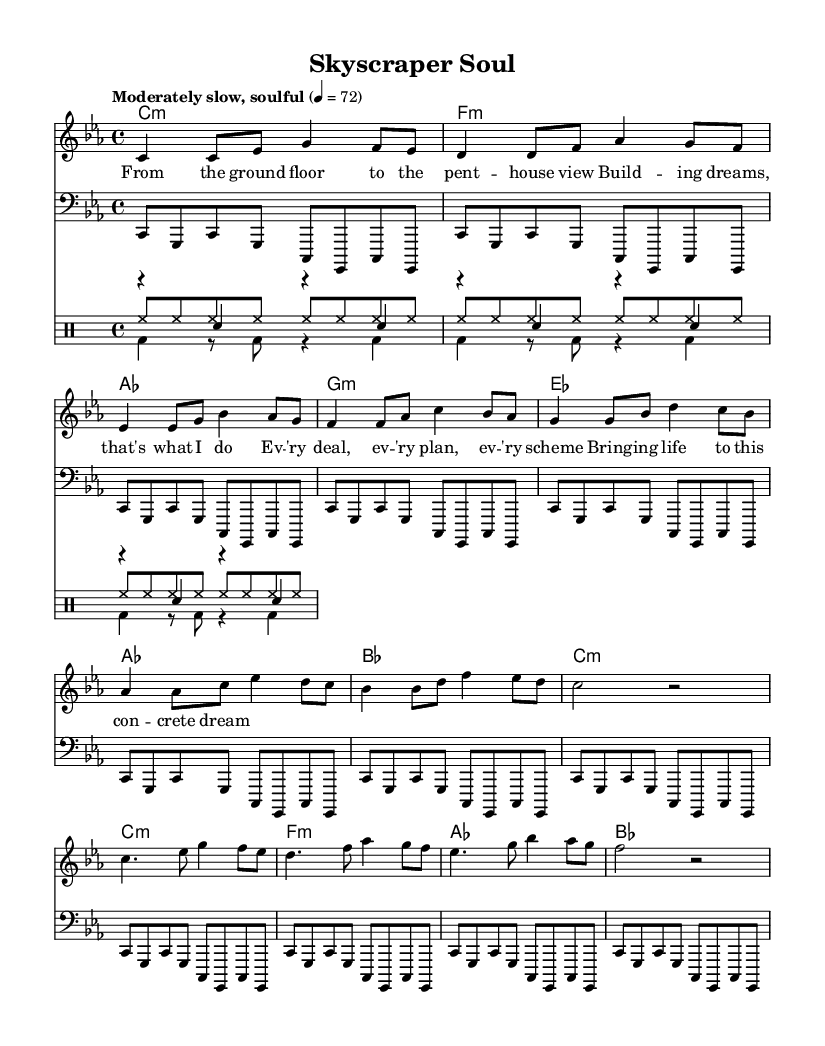What is the key signature of this music? The key signature is indicated at the beginning of the staff, showing four flats, which corresponds to C minor.
Answer: C minor What is the time signature of the piece? The time signature is found at the beginning of the score, showing a 4 over 4, indicating there are four beats in each measure.
Answer: 4/4 What is the tempo marking for this piece? The tempo marking, located above the staff, describes the pace of the music as "Moderately slow, soulful," which indicates a specific mood rather than an exact speed.
Answer: Moderately slow, soulful How many measures are in the verse? By counting the distinct groupings of notes or bars in the verse section, it can be observed that there are 4 measures before the transition to the pre-chorus.
Answer: 4 Which section comes after the pre-chorus? The structure of the song suggests that the section immediately following the pre-chorus is the chorus, as the order of musical sections of the piece indicates this.
Answer: Chorus What type of drum is represented by the notation "bd" in the drum part? In drum notation, "bd" stands for bass drum, which is indicated in the lower part where the kick pattern is written.
Answer: Bass drum How does the melody's rhythm compare between the verse and chorus? By analyzing the melody's rhythmic structure, we can see that the verse has a steadier, more consistent rhythm, while the chorus features more rhythmic variation, reflecting the heightened emotion typical of soul music.
Answer: Steadier in verse, varied in chorus 